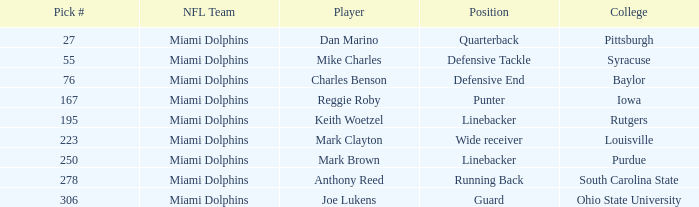Parse the full table. {'header': ['Pick #', 'NFL Team', 'Player', 'Position', 'College'], 'rows': [['27', 'Miami Dolphins', 'Dan Marino', 'Quarterback', 'Pittsburgh'], ['55', 'Miami Dolphins', 'Mike Charles', 'Defensive Tackle', 'Syracuse'], ['76', 'Miami Dolphins', 'Charles Benson', 'Defensive End', 'Baylor'], ['167', 'Miami Dolphins', 'Reggie Roby', 'Punter', 'Iowa'], ['195', 'Miami Dolphins', 'Keith Woetzel', 'Linebacker', 'Rutgers'], ['223', 'Miami Dolphins', 'Mark Clayton', 'Wide receiver', 'Louisville'], ['250', 'Miami Dolphins', 'Mark Brown', 'Linebacker', 'Purdue'], ['278', 'Miami Dolphins', 'Anthony Reed', 'Running Back', 'South Carolina State'], ['306', 'Miami Dolphins', 'Joe Lukens', 'Guard', 'Ohio State University']]} Which player possesses a selection number less than 223 and a defensive end role? Charles Benson. 